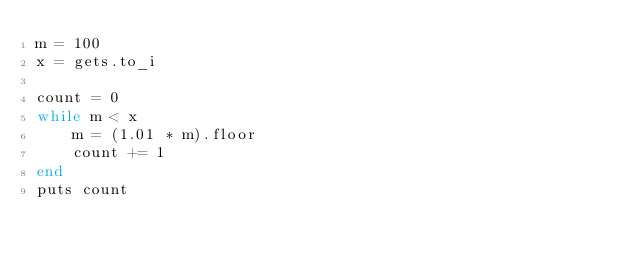<code> <loc_0><loc_0><loc_500><loc_500><_Ruby_>m = 100
x = gets.to_i

count = 0
while m < x
    m = (1.01 * m).floor
    count += 1
end
puts count
</code> 